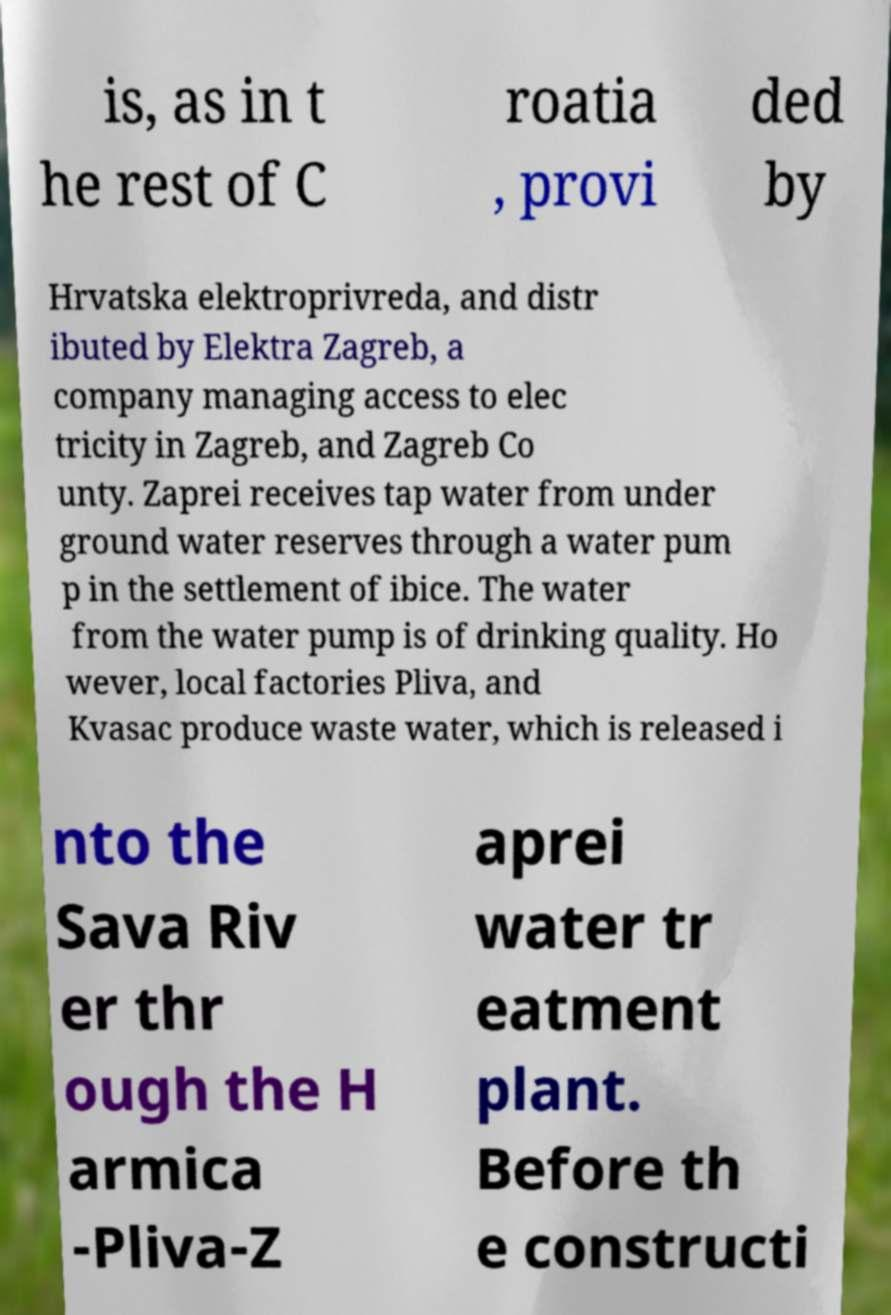Could you extract and type out the text from this image? is, as in t he rest of C roatia , provi ded by Hrvatska elektroprivreda, and distr ibuted by Elektra Zagreb, a company managing access to elec tricity in Zagreb, and Zagreb Co unty. Zaprei receives tap water from under ground water reserves through a water pum p in the settlement of ibice. The water from the water pump is of drinking quality. Ho wever, local factories Pliva, and Kvasac produce waste water, which is released i nto the Sava Riv er thr ough the H armica -Pliva-Z aprei water tr eatment plant. Before th e constructi 